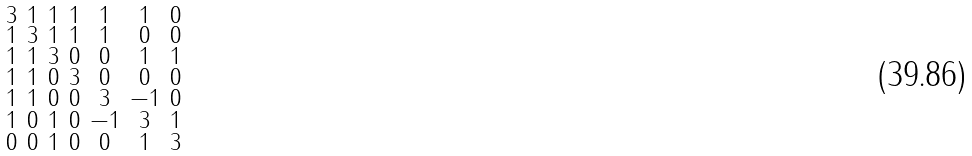<formula> <loc_0><loc_0><loc_500><loc_500>\begin{smallmatrix} 3 & 1 & 1 & 1 & 1 & 1 & 0 \\ 1 & 3 & 1 & 1 & 1 & 0 & 0 \\ 1 & 1 & 3 & 0 & 0 & 1 & 1 \\ 1 & 1 & 0 & 3 & 0 & 0 & 0 \\ 1 & 1 & 0 & 0 & 3 & - 1 & 0 \\ 1 & 0 & 1 & 0 & - 1 & 3 & 1 \\ 0 & 0 & 1 & 0 & 0 & 1 & 3 \end{smallmatrix}</formula> 